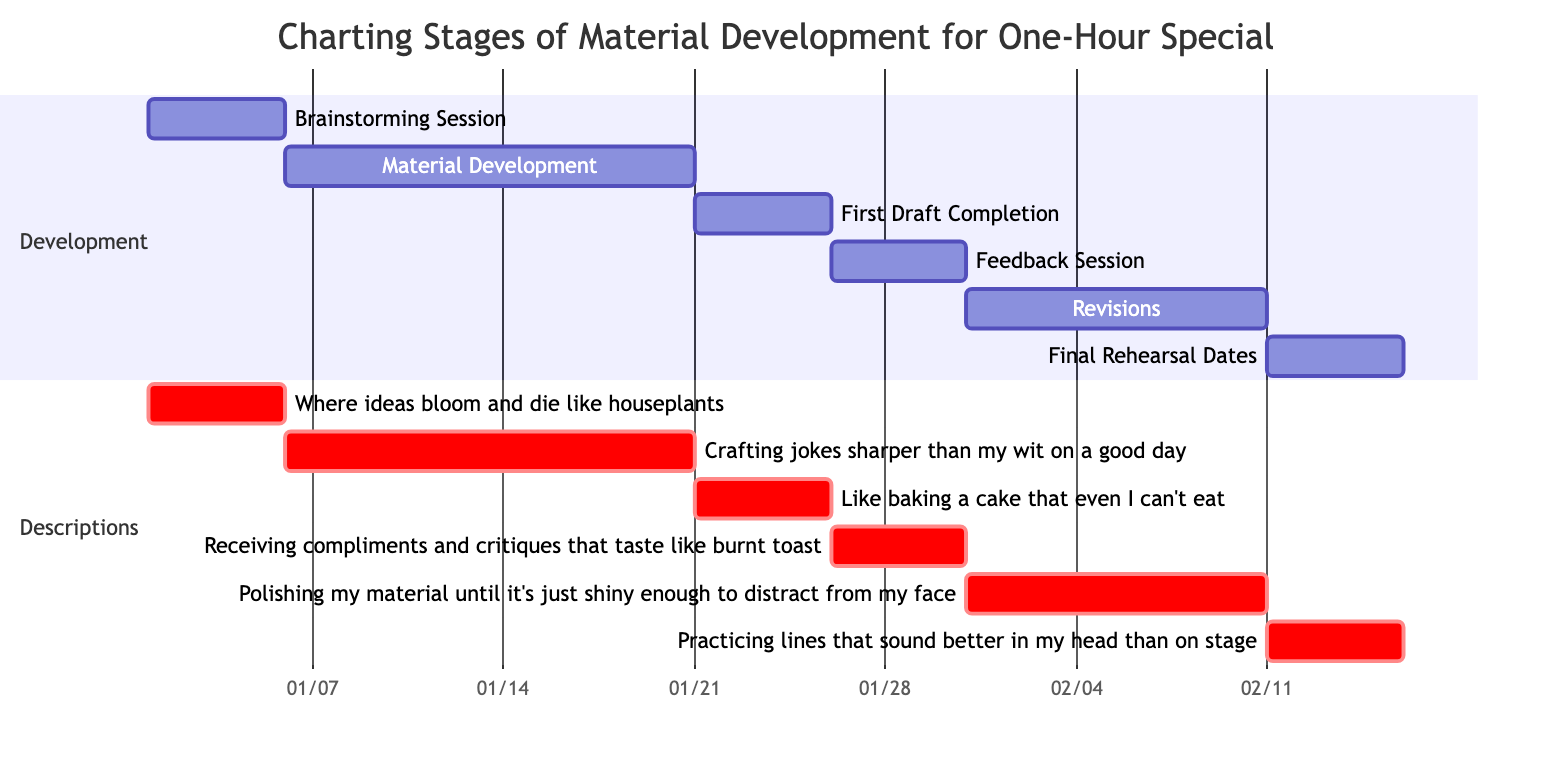What is the duration of the "Material Development" stage? The "Material Development" task starts on January 6, 2024, and ends on January 20, 2024. Counting the days from the start to the end dates gives a total of 15 days.
Answer: 15 days Which task starts immediately after the "Brainstorming Session"? The "Brainstorming Session" ends on January 5, 2024. The next task, "Material Development," starts on January 6, 2024. Therefore, "Material Development" starts immediately after.
Answer: Material Development How many total stages are represented in the diagram? The diagram lists the different stages of material development, which are Brainstorming Session, Material Development, First Draft Completion, Feedback Session, Revisions, and Final Rehearsal Dates. This totals to 6 distinct stages.
Answer: 6 What is the end date of the "Revisions" task? The "Revisions" task starts on January 31, 2024, and has a duration of 11 days, placing its end date at February 10, 2024.
Answer: 2024-02-10 Which task has the latest starting date? From the listed tasks, "Final Rehearsal Dates" starts on February 11, 2024, making it the latest starting task in the diagram compared to all other stages.
Answer: Final Rehearsal Dates What is the main focus of the "Feedback Session"? According to the description for the "Feedback Session," it focuses on receiving compliments and critiques, which indicates the aim is to gather input on the material developed.
Answer: Receiving compliments and critiques 